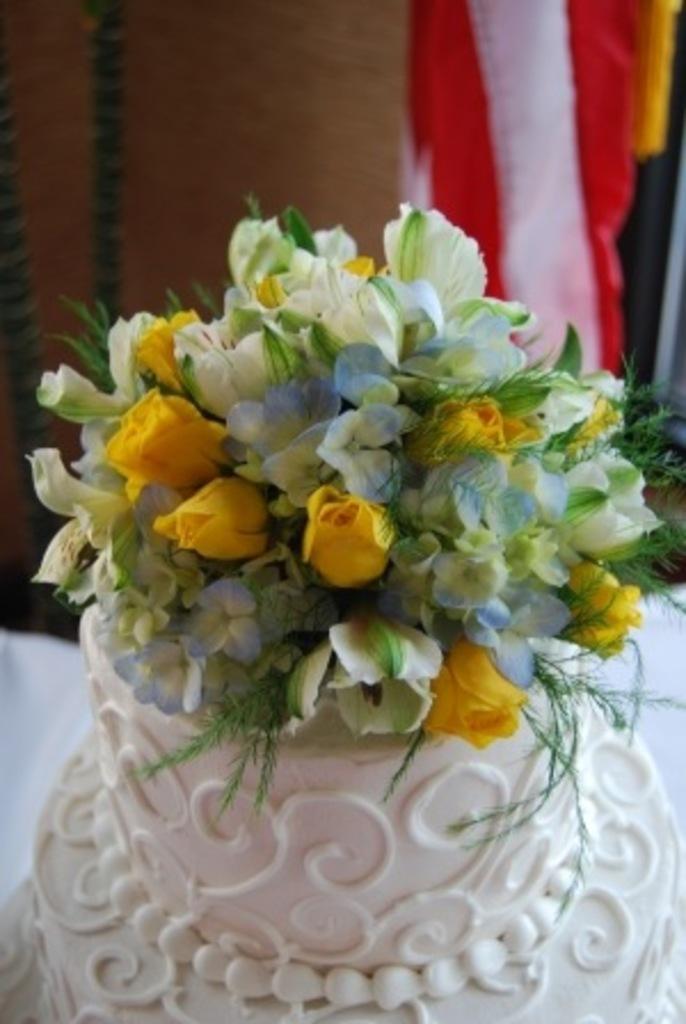Describe this image in one or two sentences. In this picture we can see flowers and leaves on a cake. In the background of the image it is blurry. 